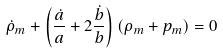<formula> <loc_0><loc_0><loc_500><loc_500>\dot { \rho } _ { m } + \left ( \frac { \dot { a } } { a } + 2 \frac { \dot { b } } { b } \right ) ( \rho _ { m } + p _ { m } ) = 0</formula> 